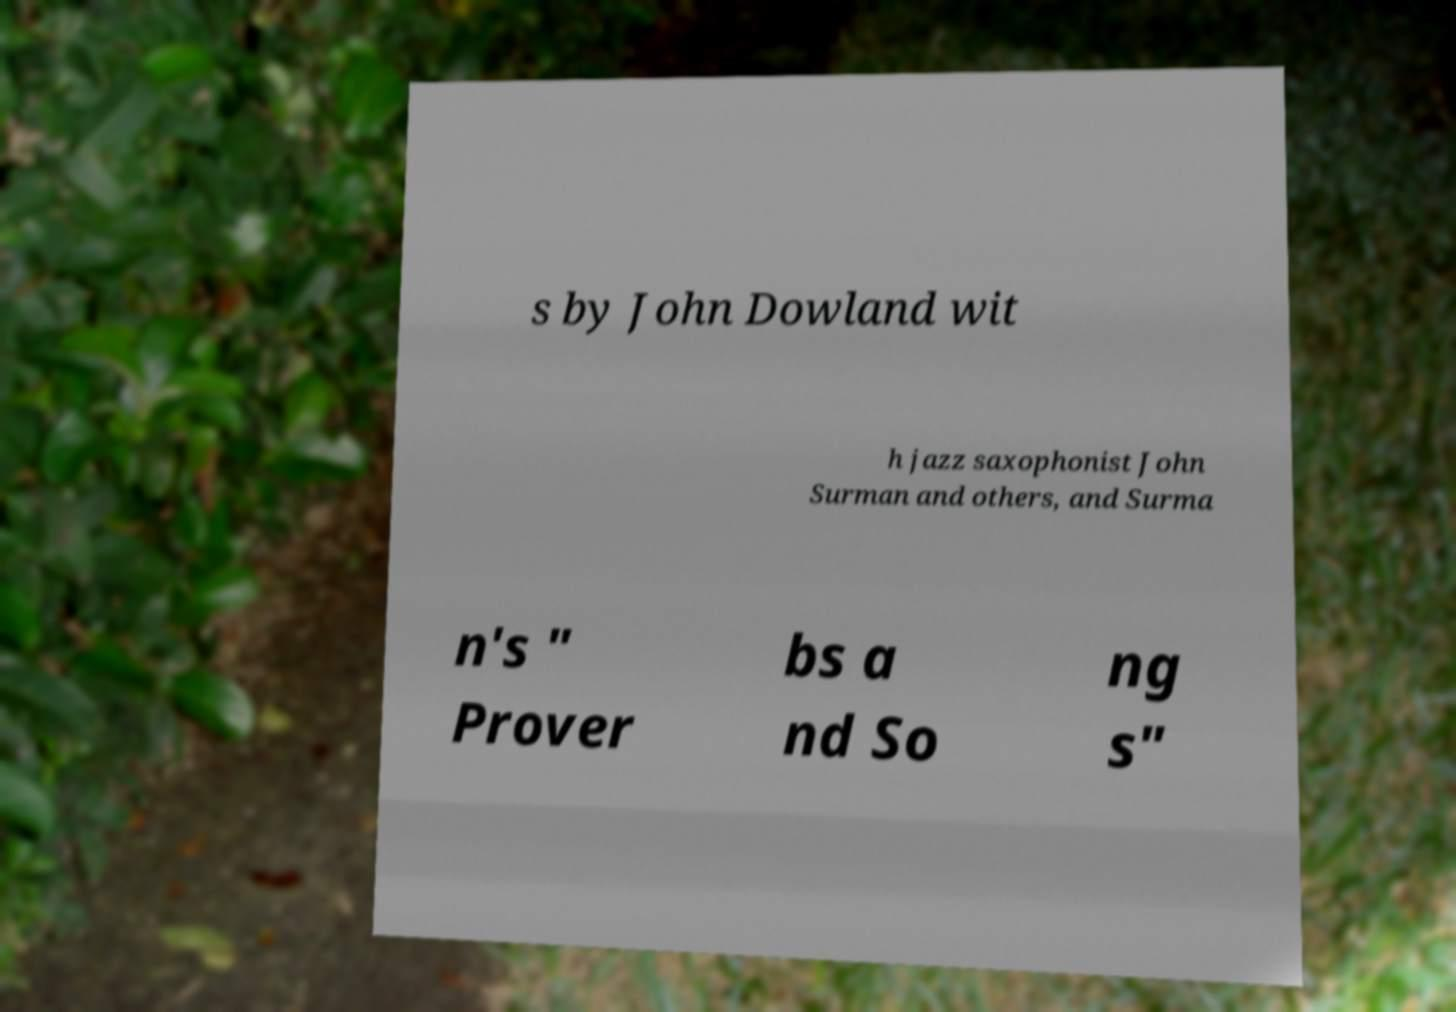Please read and relay the text visible in this image. What does it say? s by John Dowland wit h jazz saxophonist John Surman and others, and Surma n's " Prover bs a nd So ng s" 